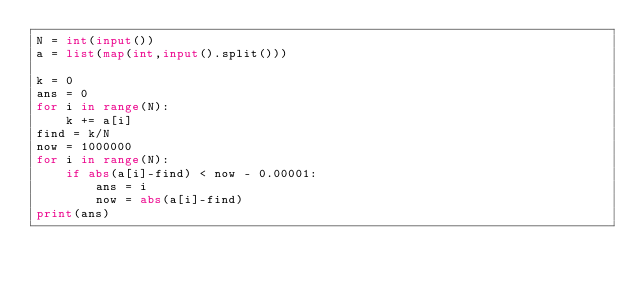Convert code to text. <code><loc_0><loc_0><loc_500><loc_500><_Python_>N = int(input())
a = list(map(int,input().split()))

k = 0
ans = 0
for i in range(N):
    k += a[i]
find = k/N
now = 1000000
for i in range(N):
    if abs(a[i]-find) < now - 0.00001:
        ans = i
        now = abs(a[i]-find)
print(ans)</code> 